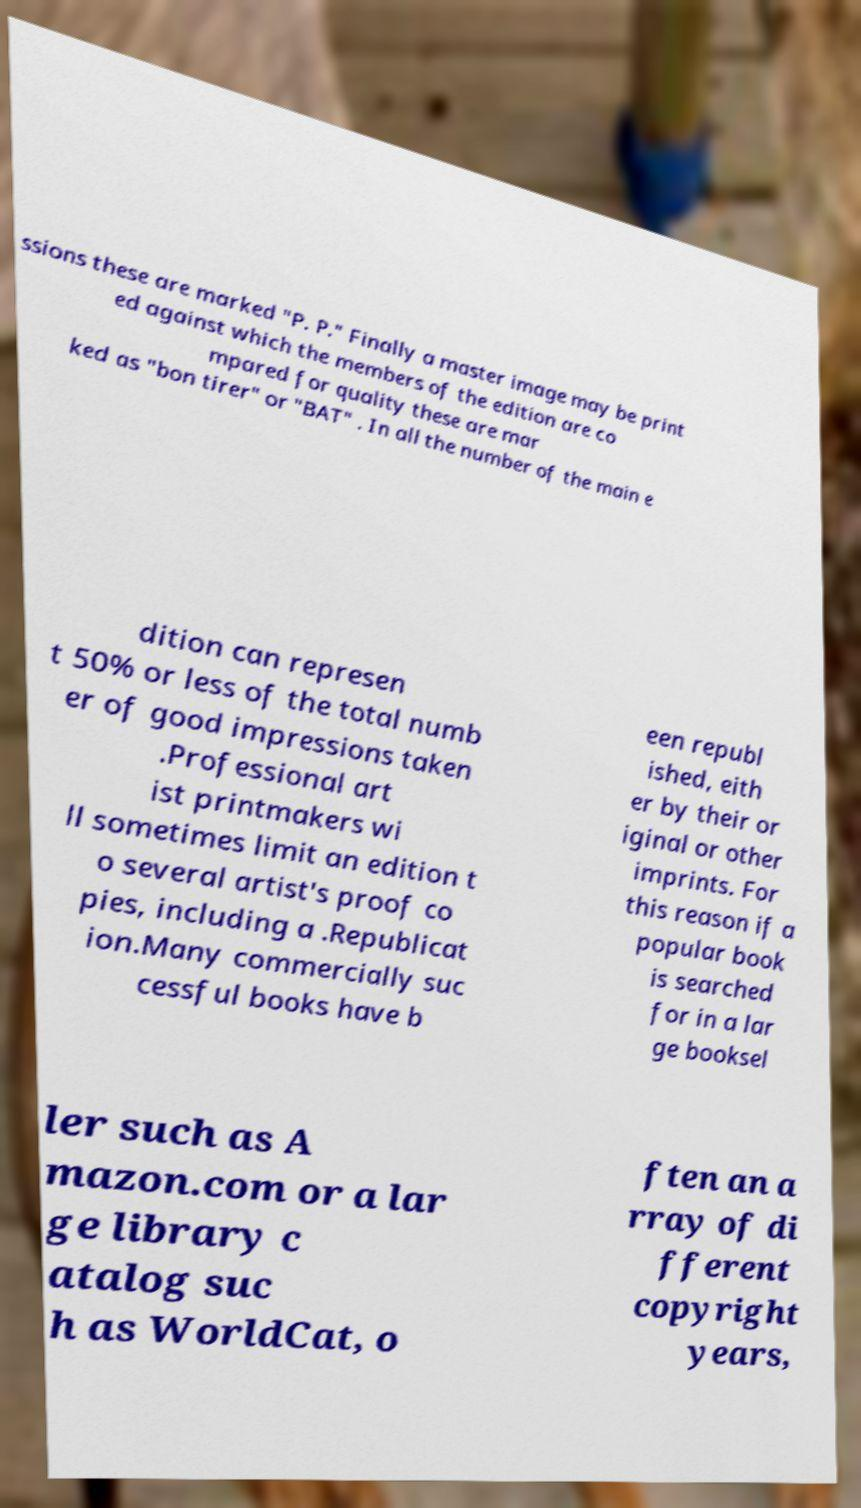For documentation purposes, I need the text within this image transcribed. Could you provide that? ssions these are marked "P. P." Finally a master image may be print ed against which the members of the edition are co mpared for quality these are mar ked as "bon tirer" or "BAT" . In all the number of the main e dition can represen t 50% or less of the total numb er of good impressions taken .Professional art ist printmakers wi ll sometimes limit an edition t o several artist's proof co pies, including a .Republicat ion.Many commercially suc cessful books have b een republ ished, eith er by their or iginal or other imprints. For this reason if a popular book is searched for in a lar ge booksel ler such as A mazon.com or a lar ge library c atalog suc h as WorldCat, o ften an a rray of di fferent copyright years, 